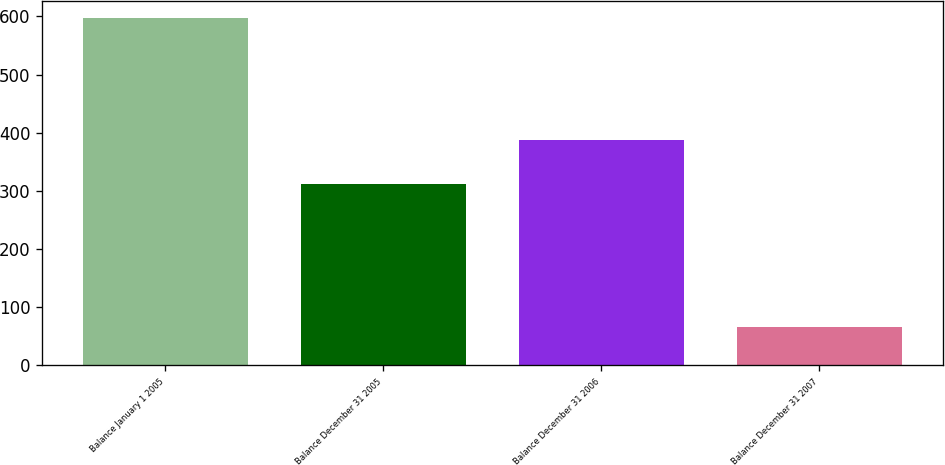Convert chart. <chart><loc_0><loc_0><loc_500><loc_500><bar_chart><fcel>Balance January 1 2005<fcel>Balance December 31 2005<fcel>Balance December 31 2006<fcel>Balance December 31 2007<nl><fcel>597<fcel>311<fcel>387<fcel>65<nl></chart> 